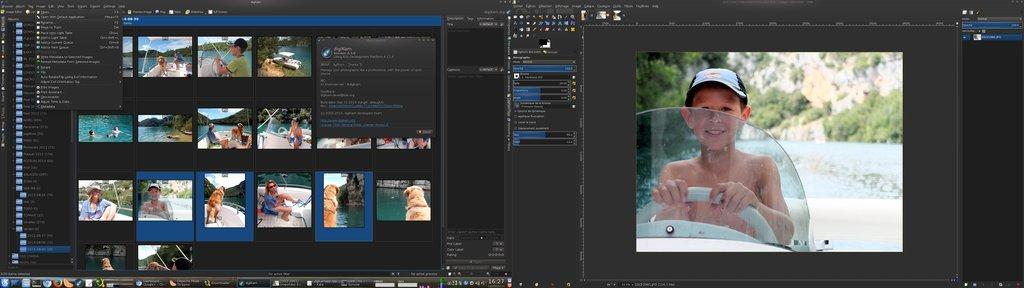What is the main subject of the image? The main subject of the image is a screenshot of a monitor screen. What type of vessel is visible in the image? There is no vessel present in the image, as it is a screenshot of a monitor screen. Can you see a zebra in the image? No, there is no zebra present in the image, as it is a screenshot of a monitor screen. 